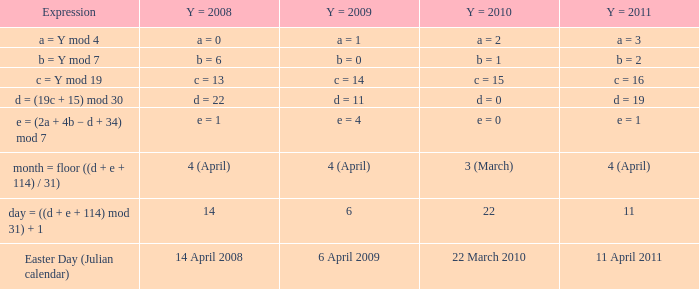What is the y = 2011 when the y = 2010 corresponds to 22nd march 2010? 11 April 2011. 